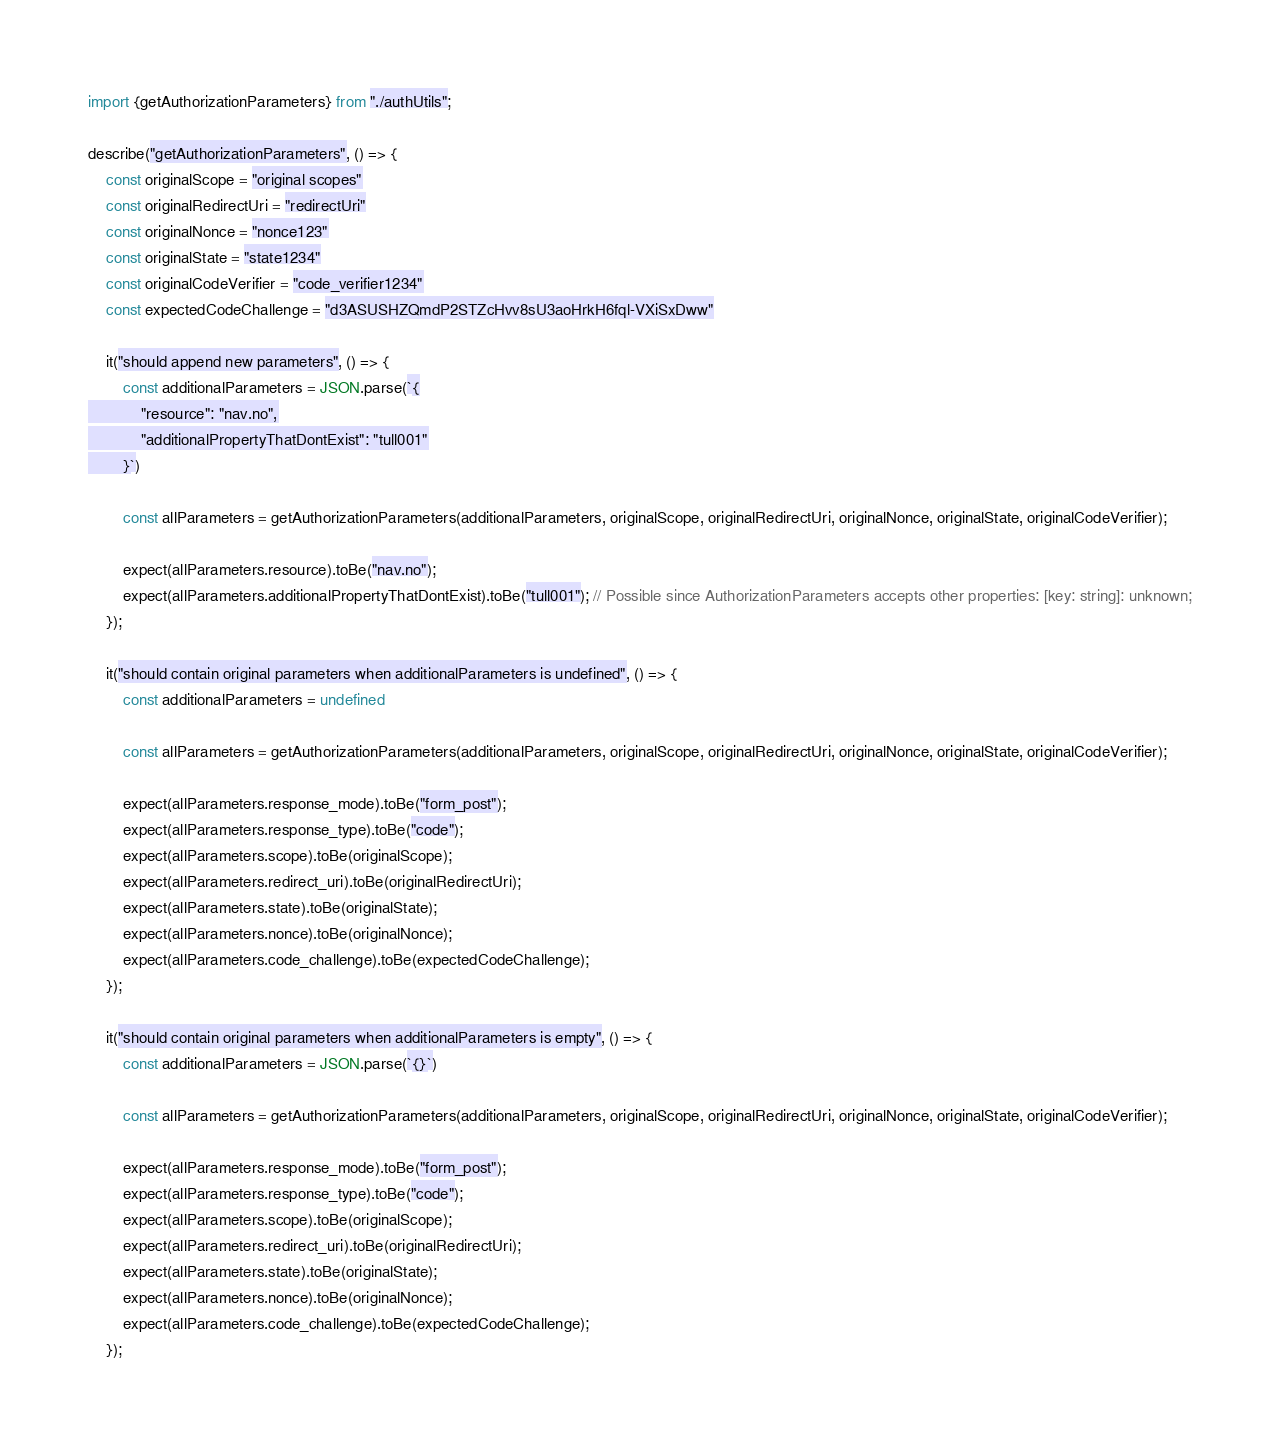Convert code to text. <code><loc_0><loc_0><loc_500><loc_500><_JavaScript_>import {getAuthorizationParameters} from "./authUtils";

describe("getAuthorizationParameters", () => {
    const originalScope = "original scopes"
    const originalRedirectUri = "redirectUri"
    const originalNonce = "nonce123"
    const originalState = "state1234"
    const originalCodeVerifier = "code_verifier1234"
    const expectedCodeChallenge = "d3ASUSHZQmdP2STZcHvv8sU3aoHrkH6fql-VXiSxDww"

    it("should append new parameters", () => {
        const additionalParameters = JSON.parse(`{
            "resource": "nav.no",
            "additionalPropertyThatDontExist": "tull001"
        }`)

        const allParameters = getAuthorizationParameters(additionalParameters, originalScope, originalRedirectUri, originalNonce, originalState, originalCodeVerifier);

        expect(allParameters.resource).toBe("nav.no");
        expect(allParameters.additionalPropertyThatDontExist).toBe("tull001"); // Possible since AuthorizationParameters accepts other properties: [key: string]: unknown;
    });

    it("should contain original parameters when additionalParameters is undefined", () => {
        const additionalParameters = undefined

        const allParameters = getAuthorizationParameters(additionalParameters, originalScope, originalRedirectUri, originalNonce, originalState, originalCodeVerifier);

        expect(allParameters.response_mode).toBe("form_post");
        expect(allParameters.response_type).toBe("code");
        expect(allParameters.scope).toBe(originalScope);
        expect(allParameters.redirect_uri).toBe(originalRedirectUri);
        expect(allParameters.state).toBe(originalState);
        expect(allParameters.nonce).toBe(originalNonce);
        expect(allParameters.code_challenge).toBe(expectedCodeChallenge);
    });

    it("should contain original parameters when additionalParameters is empty", () => {
        const additionalParameters = JSON.parse(`{}`)

        const allParameters = getAuthorizationParameters(additionalParameters, originalScope, originalRedirectUri, originalNonce, originalState, originalCodeVerifier);

        expect(allParameters.response_mode).toBe("form_post");
        expect(allParameters.response_type).toBe("code");
        expect(allParameters.scope).toBe(originalScope);
        expect(allParameters.redirect_uri).toBe(originalRedirectUri);
        expect(allParameters.state).toBe(originalState);
        expect(allParameters.nonce).toBe(originalNonce);
        expect(allParameters.code_challenge).toBe(expectedCodeChallenge);
    });
</code> 